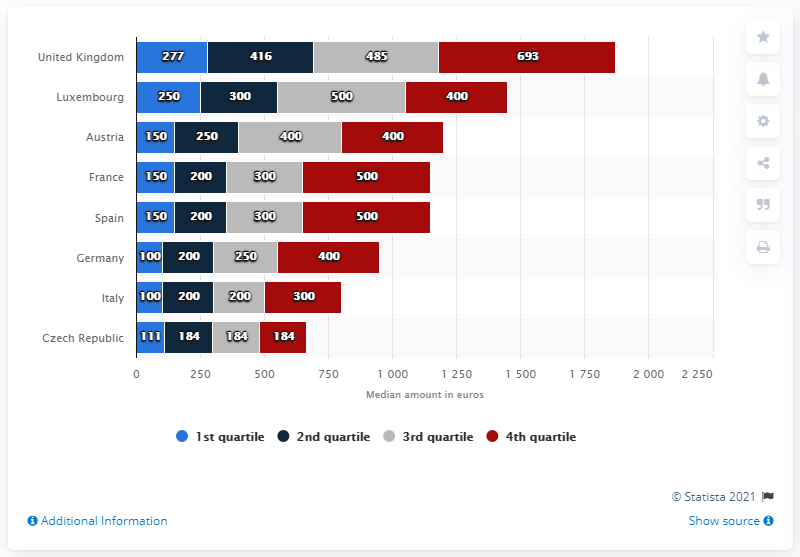Point out several critical features in this image. In 2015, the United Kingdom spent the most money out of all the countries. In the least developed country, there is a total of 663 quartiles. Austria is ranked highest in the 3rd quartile. 